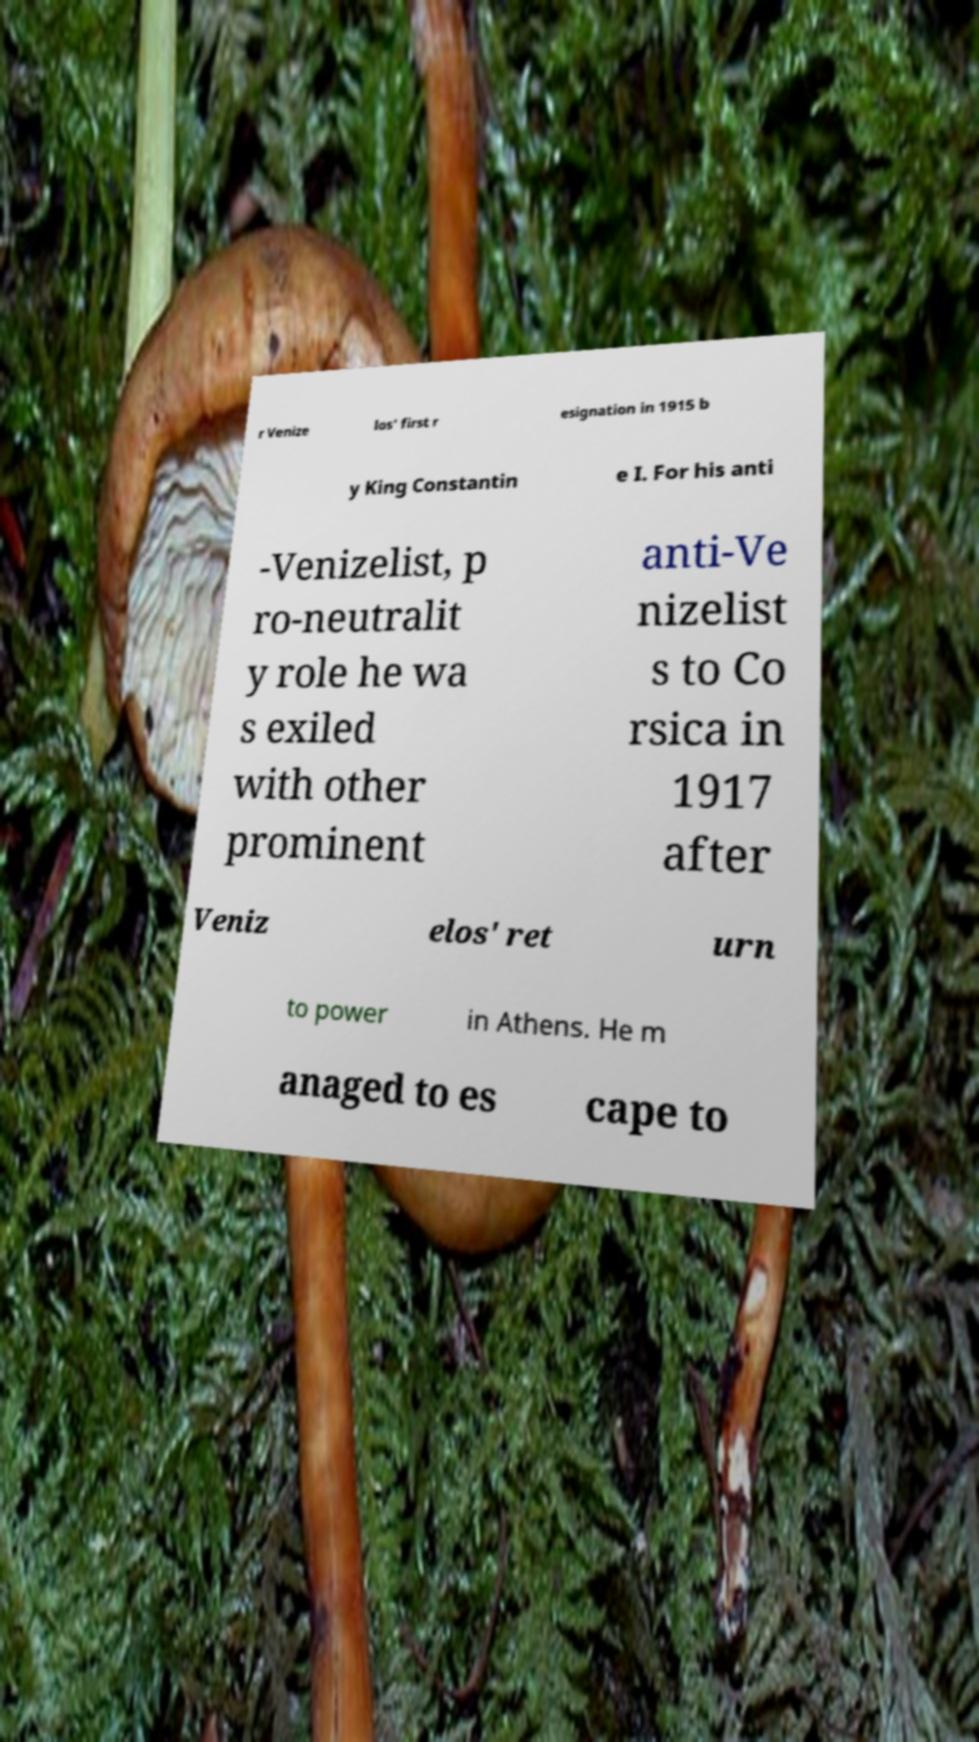Please identify and transcribe the text found in this image. r Venize los' first r esignation in 1915 b y King Constantin e I. For his anti -Venizelist, p ro-neutralit y role he wa s exiled with other prominent anti-Ve nizelist s to Co rsica in 1917 after Veniz elos' ret urn to power in Athens. He m anaged to es cape to 